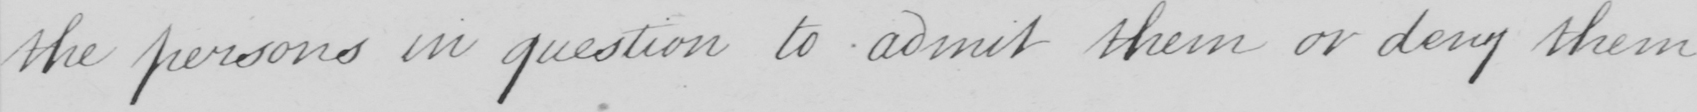What does this handwritten line say? the persons in question to admit them or deny them 